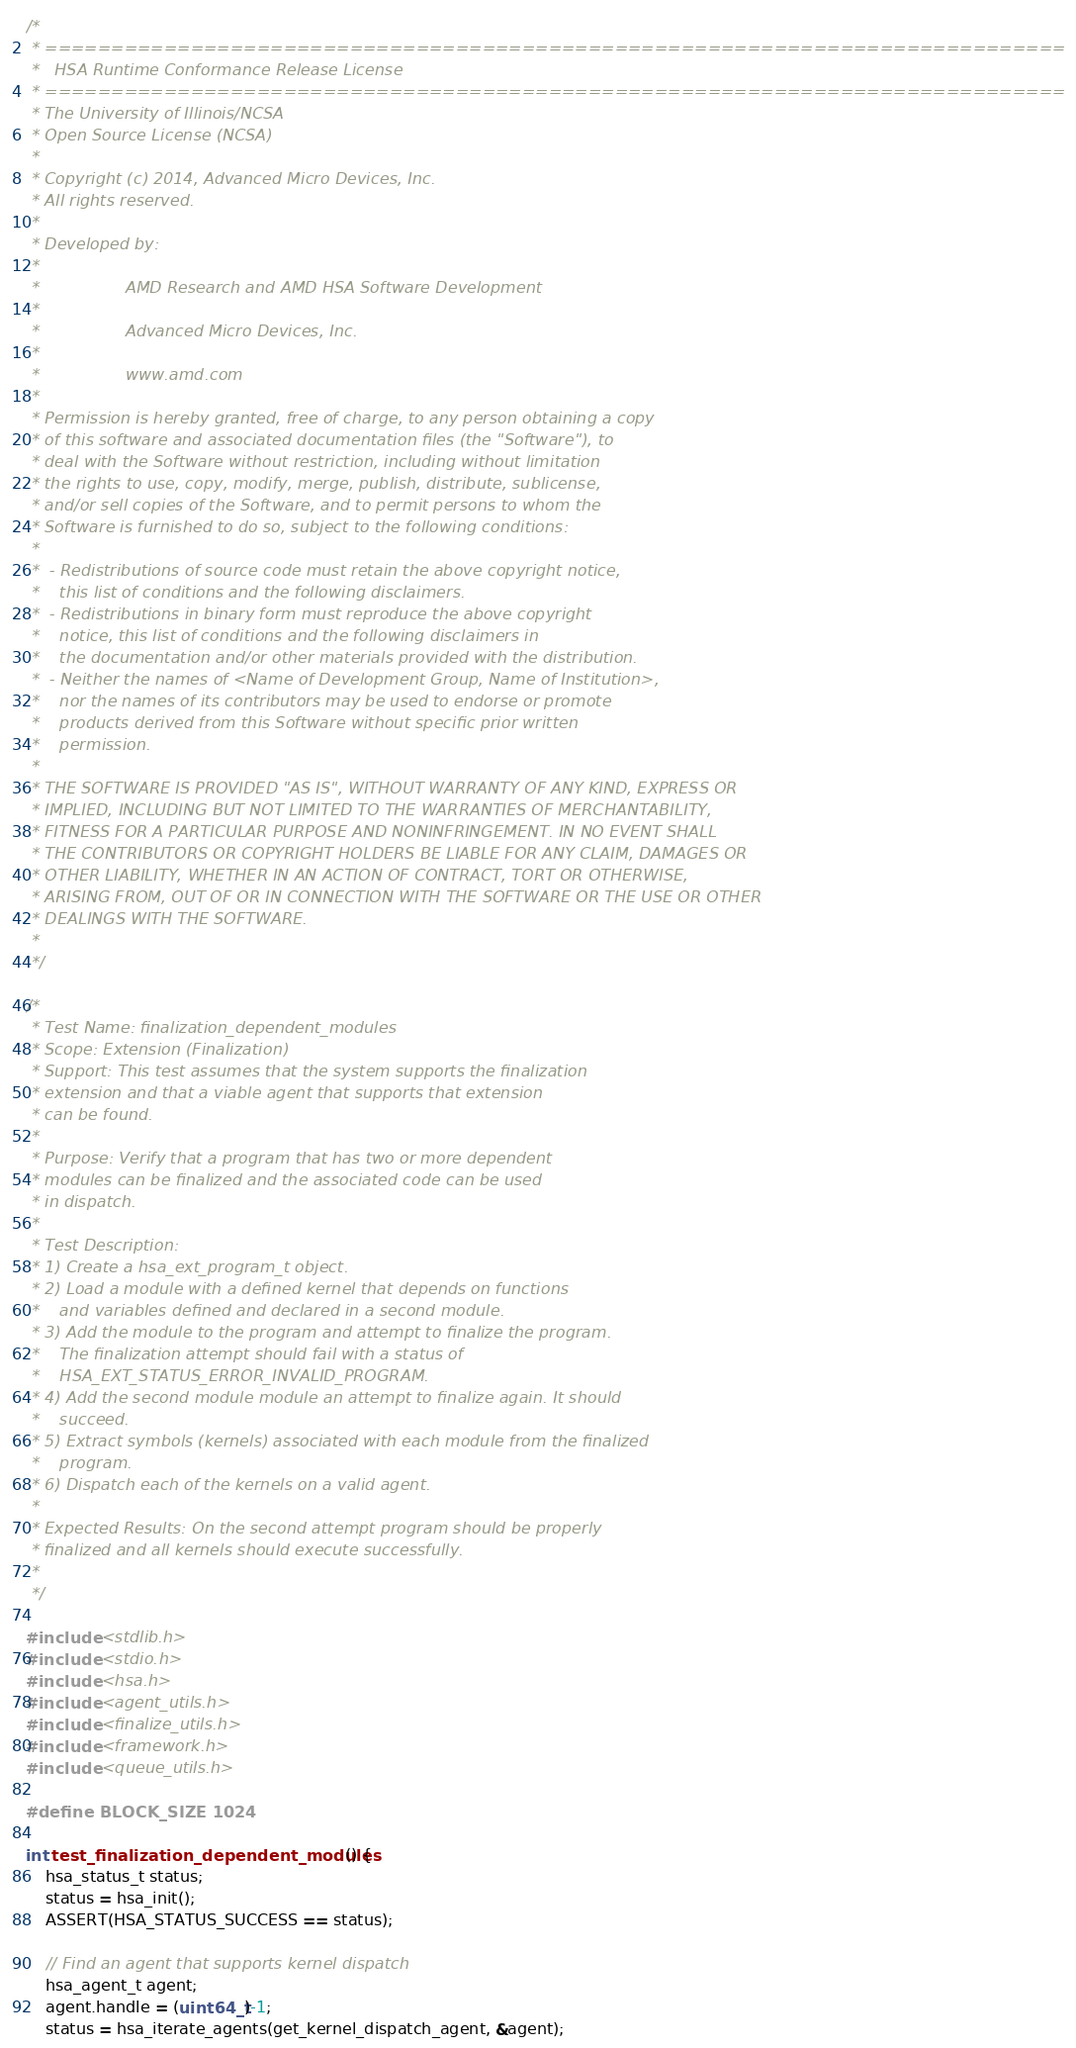Convert code to text. <code><loc_0><loc_0><loc_500><loc_500><_C_>/*
 * =============================================================================
 *   HSA Runtime Conformance Release License
 * =============================================================================
 * The University of Illinois/NCSA
 * Open Source License (NCSA)
 *
 * Copyright (c) 2014, Advanced Micro Devices, Inc.
 * All rights reserved.
 *
 * Developed by:
 *
 *                 AMD Research and AMD HSA Software Development
 *
 *                 Advanced Micro Devices, Inc.
 *
 *                 www.amd.com
 *
 * Permission is hereby granted, free of charge, to any person obtaining a copy
 * of this software and associated documentation files (the "Software"), to
 * deal with the Software without restriction, including without limitation
 * the rights to use, copy, modify, merge, publish, distribute, sublicense,
 * and/or sell copies of the Software, and to permit persons to whom the
 * Software is furnished to do so, subject to the following conditions:
 *
 *  - Redistributions of source code must retain the above copyright notice,
 *    this list of conditions and the following disclaimers.
 *  - Redistributions in binary form must reproduce the above copyright
 *    notice, this list of conditions and the following disclaimers in
 *    the documentation and/or other materials provided with the distribution.
 *  - Neither the names of <Name of Development Group, Name of Institution>,
 *    nor the names of its contributors may be used to endorse or promote
 *    products derived from this Software without specific prior written
 *    permission.
 *
 * THE SOFTWARE IS PROVIDED "AS IS", WITHOUT WARRANTY OF ANY KIND, EXPRESS OR
 * IMPLIED, INCLUDING BUT NOT LIMITED TO THE WARRANTIES OF MERCHANTABILITY,
 * FITNESS FOR A PARTICULAR PURPOSE AND NONINFRINGEMENT. IN NO EVENT SHALL
 * THE CONTRIBUTORS OR COPYRIGHT HOLDERS BE LIABLE FOR ANY CLAIM, DAMAGES OR
 * OTHER LIABILITY, WHETHER IN AN ACTION OF CONTRACT, TORT OR OTHERWISE,
 * ARISING FROM, OUT OF OR IN CONNECTION WITH THE SOFTWARE OR THE USE OR OTHER
 * DEALINGS WITH THE SOFTWARE.
 *
 */

/*
 * Test Name: finalization_dependent_modules
 * Scope: Extension (Finalization)
 * Support: This test assumes that the system supports the finalization
 * extension and that a viable agent that supports that extension
 * can be found.
 *
 * Purpose: Verify that a program that has two or more dependent
 * modules can be finalized and the associated code can be used
 * in dispatch.
 *
 * Test Description:
 * 1) Create a hsa_ext_program_t object.
 * 2) Load a module with a defined kernel that depends on functions
 *    and variables defined and declared in a second module.
 * 3) Add the module to the program and attempt to finalize the program.
 *    The finalization attempt should fail with a status of
 *    HSA_EXT_STATUS_ERROR_INVALID_PROGRAM.
 * 4) Add the second module module an attempt to finalize again. It should
 *    succeed.
 * 5) Extract symbols (kernels) associated with each module from the finalized
 *    program.
 * 6) Dispatch each of the kernels on a valid agent.
 *
 * Expected Results: On the second attempt program should be properly
 * finalized and all kernels should execute successfully.
 *
 */

#include <stdlib.h>
#include <stdio.h>
#include <hsa.h>
#include <agent_utils.h>
#include <finalize_utils.h>
#include <framework.h>
#include <queue_utils.h>

#define BLOCK_SIZE 1024

int test_finalization_dependent_modules() {
    hsa_status_t status;
    status = hsa_init();
    ASSERT(HSA_STATUS_SUCCESS == status);

    // Find an agent that supports kernel dispatch
    hsa_agent_t agent;
    agent.handle = (uint64_t)-1;
    status = hsa_iterate_agents(get_kernel_dispatch_agent, &agent);</code> 